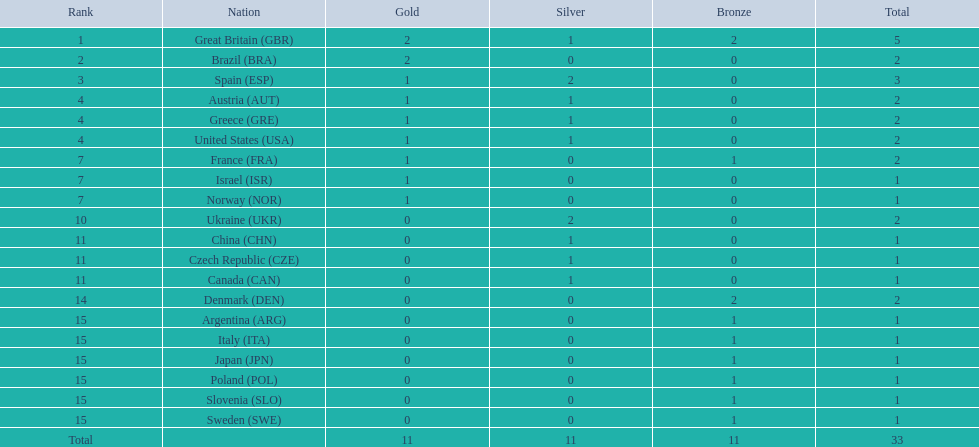What was the medal tally for each country? 5, 2, 3, 2, 2, 2, 2, 1, 1, 2, 1, 1, 1, 2, 1, 1, 1, 1, 1, 1. Which country had a total of 3 medals? Spain (ESP). 